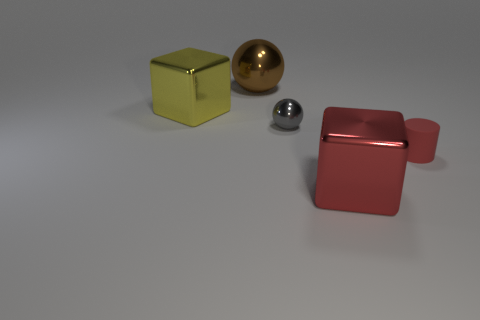Add 5 cyan shiny cylinders. How many objects exist? 10 Subtract all cylinders. How many objects are left? 4 Subtract all big objects. Subtract all red shiny things. How many objects are left? 1 Add 2 brown things. How many brown things are left? 3 Add 3 tiny rubber objects. How many tiny rubber objects exist? 4 Subtract 0 cyan cylinders. How many objects are left? 5 